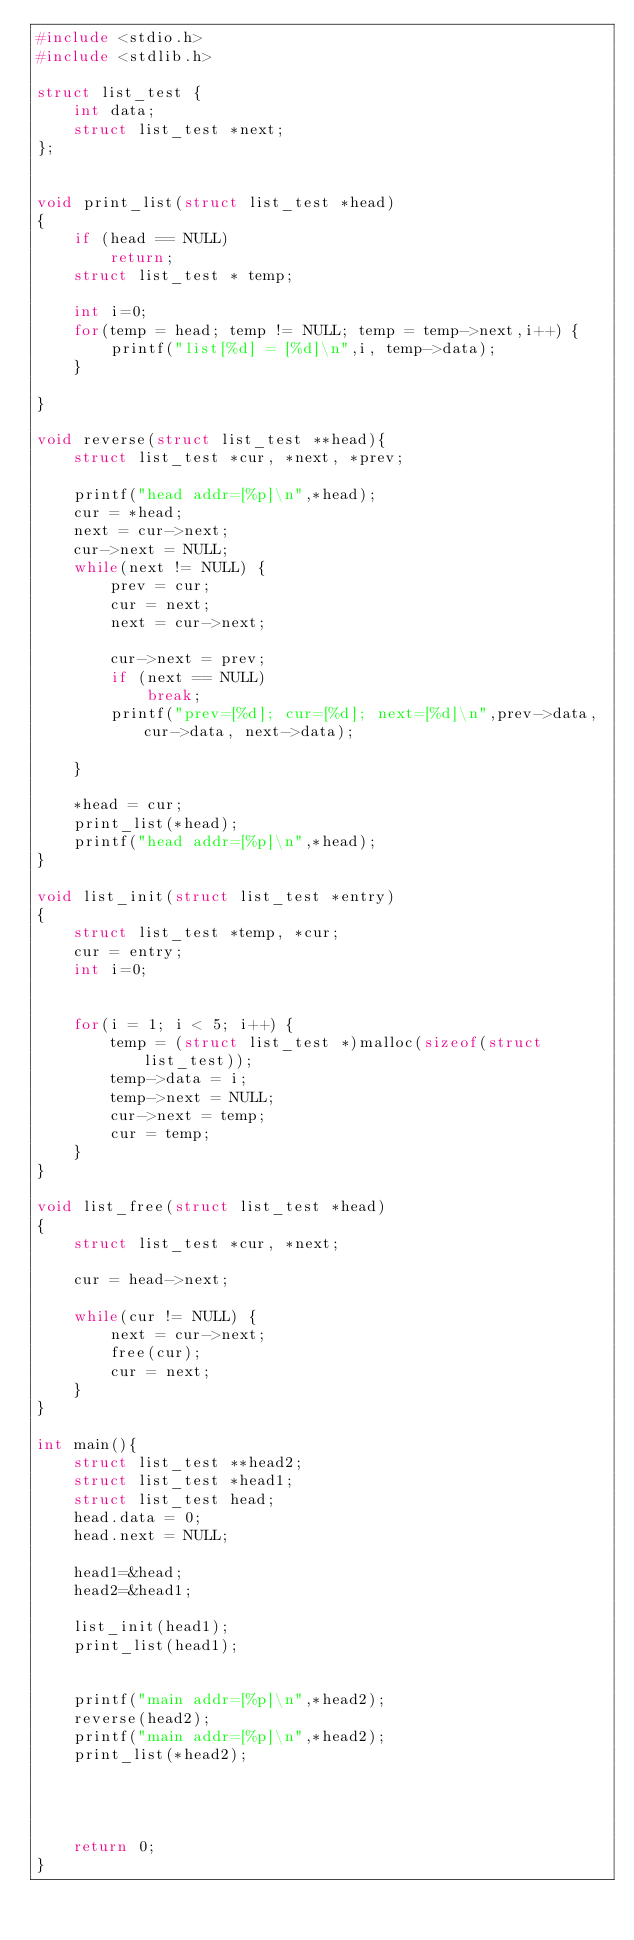Convert code to text. <code><loc_0><loc_0><loc_500><loc_500><_C_>#include <stdio.h>
#include <stdlib.h>

struct list_test {
	int data;
	struct list_test *next;
};


void print_list(struct list_test *head)
{
	if (head == NULL)
		return;
	struct list_test * temp;
	
	int i=0;
	for(temp = head; temp != NULL; temp = temp->next,i++) {
		printf("list[%d] = [%d]\n",i, temp->data);
	}

}

void reverse(struct list_test **head){
	struct list_test *cur, *next, *prev;

	printf("head addr=[%p]\n",*head);
	cur = *head;
	next = cur->next;
	cur->next = NULL;
	while(next != NULL) {
		prev = cur;
		cur = next;
		next = cur->next;
		
		cur->next = prev;
		if (next == NULL)
			break;
		printf("prev=[%d]; cur=[%d]; next=[%d]\n",prev->data, cur->data, next->data);

	}
	
	*head = cur;
	print_list(*head);	
	printf("head addr=[%p]\n",*head);
}

void list_init(struct list_test *entry)
{
	struct list_test *temp, *cur;
	cur = entry;
	int i=0;


	for(i = 1; i < 5; i++) {
		temp = (struct list_test *)malloc(sizeof(struct list_test));
		temp->data = i;
		temp->next = NULL;
		cur->next = temp;
		cur = temp;
	}
}

void list_free(struct list_test *head)
{
	struct list_test *cur, *next;
	
	cur = head->next;

	while(cur != NULL) {
		next = cur->next;
		free(cur);
		cur = next;
	}
}

int main(){
	struct list_test **head2;
	struct list_test *head1;
	struct list_test head;
	head.data = 0;
	head.next = NULL;

	head1=&head;
	head2=&head1;
	
	list_init(head1);
	print_list(head1);
	
	
	printf("main addr=[%p]\n",*head2);
	reverse(head2);
	printf("main addr=[%p]\n",*head2);
	print_list(*head2);




	return 0;
}


		

	
	
</code> 